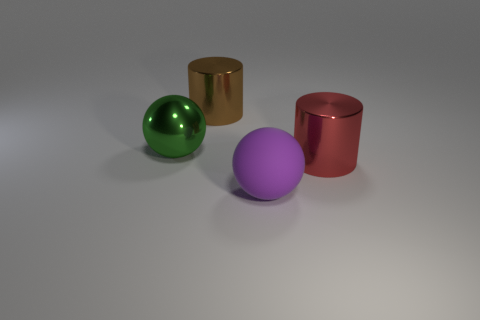What shape is the large thing that is both in front of the large brown thing and to the left of the purple matte thing?
Your response must be concise. Sphere. The ball on the right side of the shiny thing that is to the left of the big metal cylinder that is on the left side of the large purple rubber object is made of what material?
Make the answer very short. Rubber. Is the number of objects to the right of the big purple object greater than the number of big red cylinders that are to the left of the brown shiny object?
Provide a short and direct response. Yes. What number of green spheres are made of the same material as the big green thing?
Your answer should be very brief. 0. Do the big brown thing behind the large red cylinder and the big green object that is on the left side of the large rubber thing have the same shape?
Your answer should be very brief. No. There is a cylinder behind the big red object; what color is it?
Provide a succinct answer. Brown. Is there a big purple object of the same shape as the big brown shiny object?
Provide a succinct answer. No. What is the material of the red object?
Your answer should be compact. Metal. There is a object that is behind the rubber ball and right of the large brown metal object; what is its size?
Ensure brevity in your answer.  Large. What number of small brown cubes are there?
Your answer should be very brief. 0. 